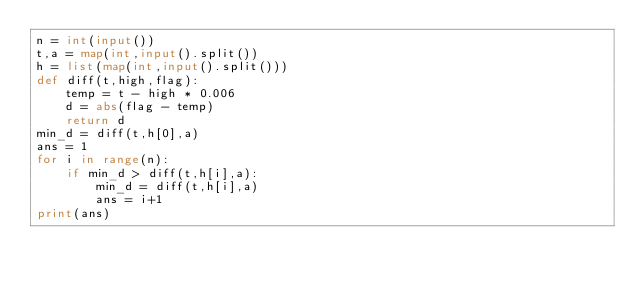<code> <loc_0><loc_0><loc_500><loc_500><_Python_>n = int(input())
t,a = map(int,input().split())
h = list(map(int,input().split()))
def diff(t,high,flag):
    temp = t - high * 0.006
    d = abs(flag - temp)
    return d
min_d = diff(t,h[0],a)
ans = 1
for i in range(n):
    if min_d > diff(t,h[i],a):
        min_d = diff(t,h[i],a)
        ans = i+1
print(ans)</code> 